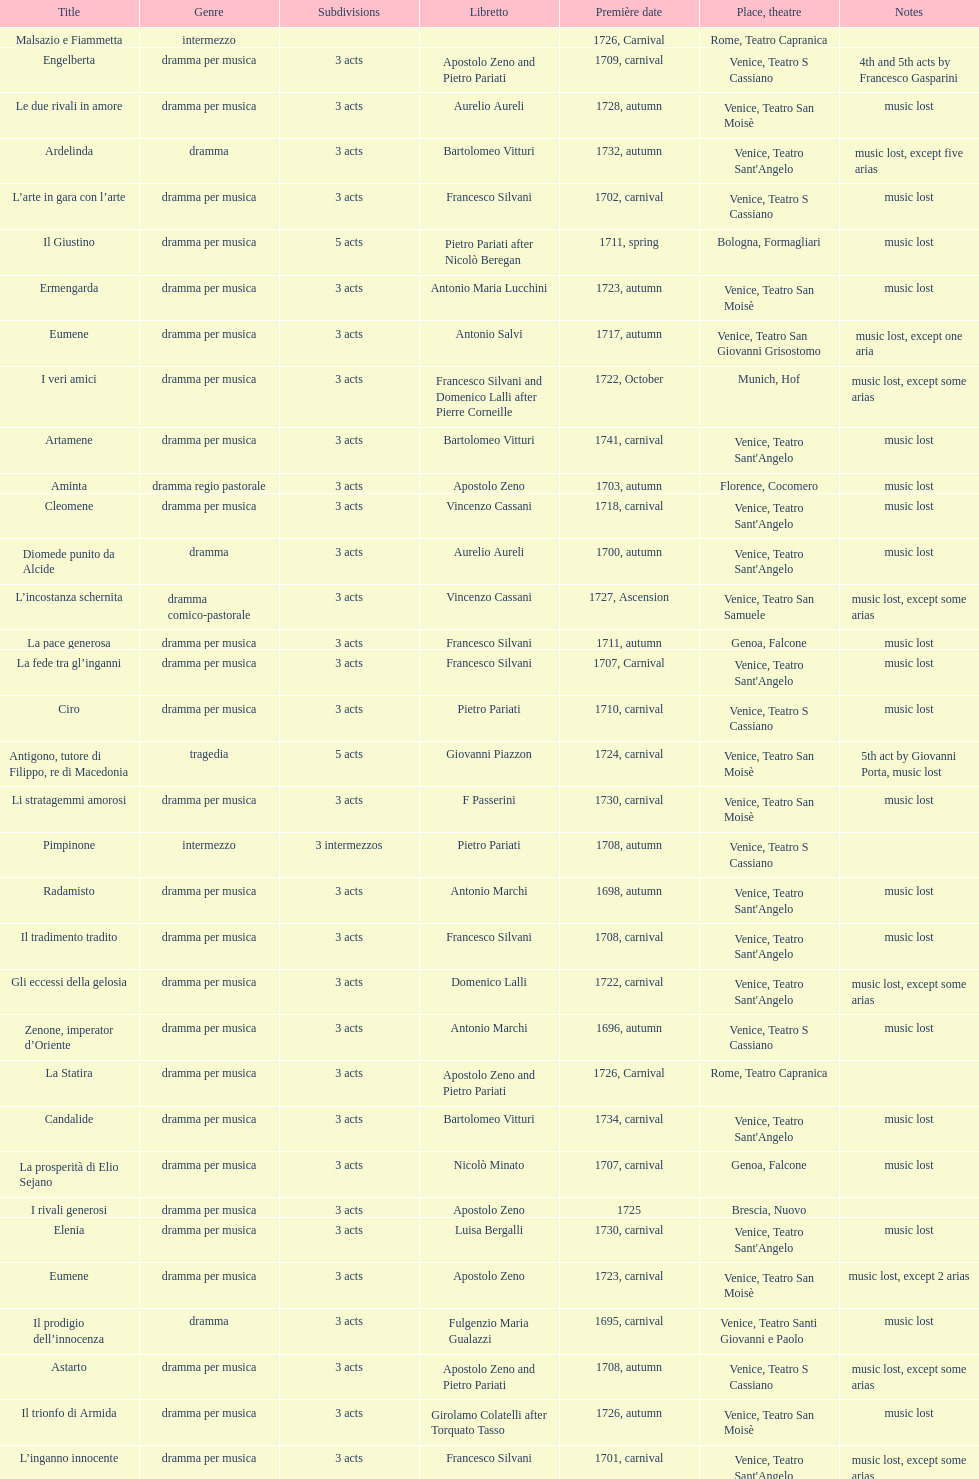After zenone, imperator d'oriente, what was the number of releases? 52. 